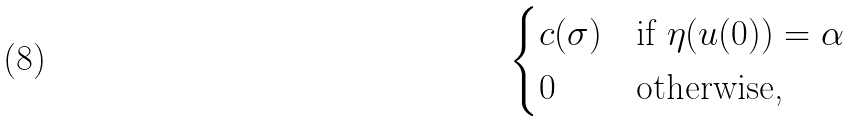<formula> <loc_0><loc_0><loc_500><loc_500>\begin{cases} c ( \sigma ) & \text {if $\eta(u(0))=\alpha$} \\ 0 & \text {otherwise,} \end{cases}</formula> 